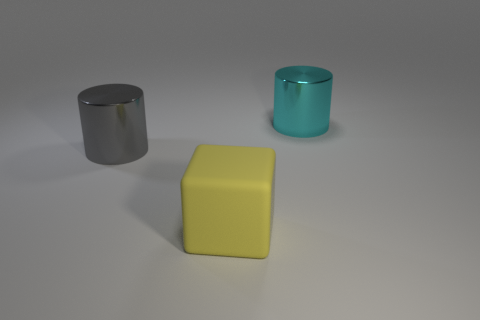Is there any other thing that is made of the same material as the large yellow object?
Provide a succinct answer. No. Is the number of large yellow matte blocks that are left of the yellow block less than the number of gray metallic cylinders behind the large gray thing?
Offer a very short reply. No. Does the cyan shiny cylinder behind the yellow matte block have the same size as the big gray metallic object?
Ensure brevity in your answer.  Yes. There is a big thing to the right of the big matte thing; what shape is it?
Keep it short and to the point. Cylinder. Is the number of purple matte cylinders greater than the number of big gray metal objects?
Your answer should be compact. No. How many objects are big things to the left of the yellow block or cylinders in front of the large cyan shiny object?
Your answer should be very brief. 1. What number of things are both to the left of the cyan metal thing and behind the big block?
Offer a terse response. 1. Does the gray cylinder have the same material as the large cyan thing?
Your response must be concise. Yes. The big object that is in front of the large metal object that is left of the large metal cylinder on the right side of the big matte thing is what shape?
Offer a very short reply. Cube. There is a large thing that is both behind the cube and on the right side of the gray metallic thing; what is its material?
Keep it short and to the point. Metal. 